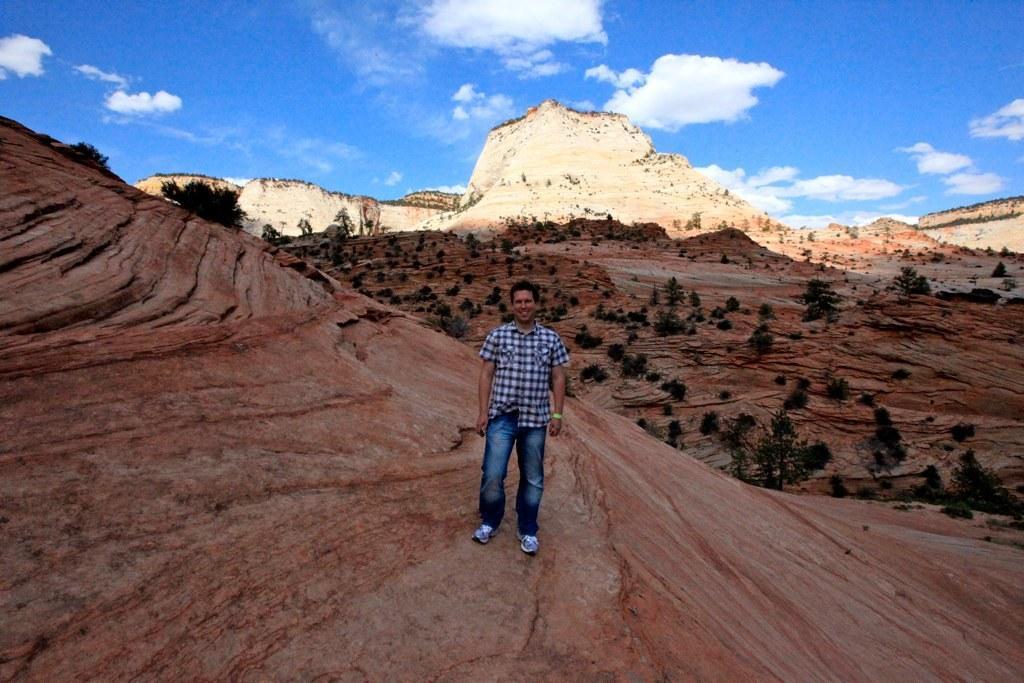In one or two sentences, can you explain what this image depicts? In the foreground of this image, there is a man standing on the rock like surface. In the background, there are trees, mountains, sky and the cloud. 